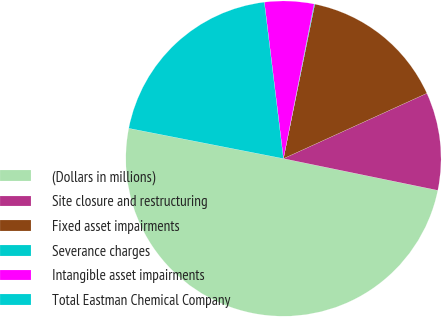Convert chart to OTSL. <chart><loc_0><loc_0><loc_500><loc_500><pie_chart><fcel>(Dollars in millions)<fcel>Site closure and restructuring<fcel>Fixed asset impairments<fcel>Severance charges<fcel>Intangible asset impairments<fcel>Total Eastman Chemical Company<nl><fcel>49.85%<fcel>10.03%<fcel>15.01%<fcel>0.07%<fcel>5.05%<fcel>19.99%<nl></chart> 